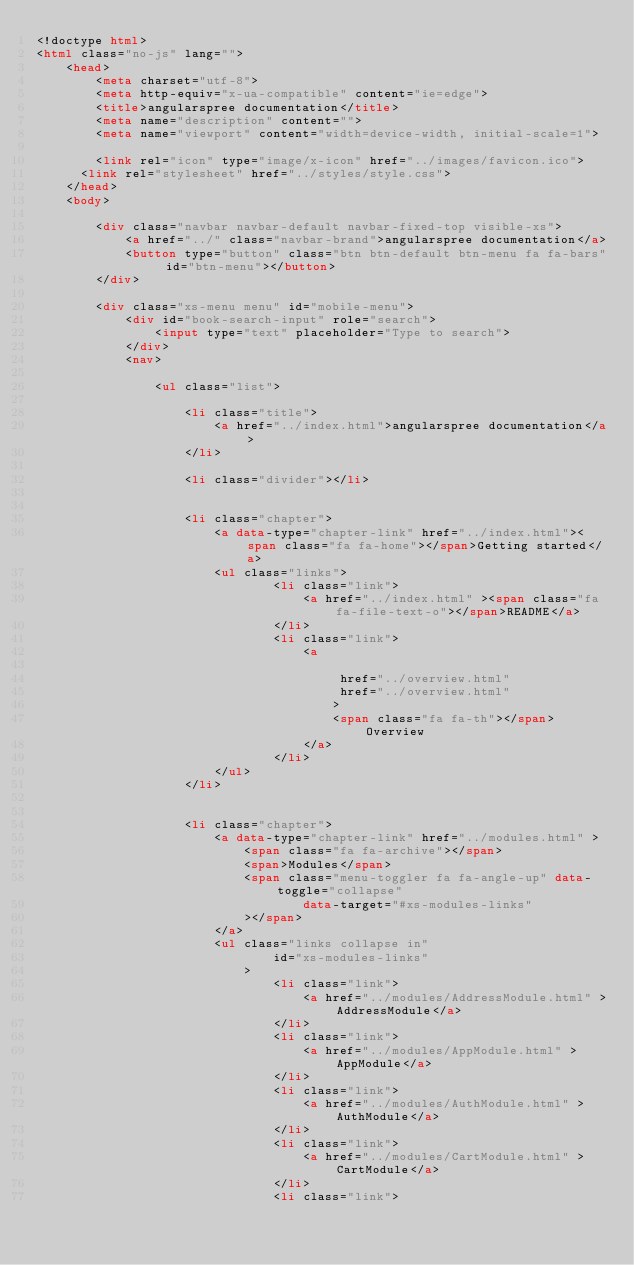Convert code to text. <code><loc_0><loc_0><loc_500><loc_500><_HTML_><!doctype html>
<html class="no-js" lang="">
    <head>
        <meta charset="utf-8">
        <meta http-equiv="x-ua-compatible" content="ie=edge">
        <title>angularspree documentation</title>
        <meta name="description" content="">
        <meta name="viewport" content="width=device-width, initial-scale=1">

        <link rel="icon" type="image/x-icon" href="../images/favicon.ico">
	    <link rel="stylesheet" href="../styles/style.css">
    </head>
    <body>

        <div class="navbar navbar-default navbar-fixed-top visible-xs">
            <a href="../" class="navbar-brand">angularspree documentation</a>
            <button type="button" class="btn btn-default btn-menu fa fa-bars" id="btn-menu"></button>
        </div>

        <div class="xs-menu menu" id="mobile-menu">
            <div id="book-search-input" role="search">
                <input type="text" placeholder="Type to search">
            </div>
            <nav>

                <ul class="list">

                    <li class="title">
                        <a href="../index.html">angularspree documentation</a>
                    </li>

                    <li class="divider"></li>


                    <li class="chapter">
                        <a data-type="chapter-link" href="../index.html"><span class="fa fa-home"></span>Getting started</a>
                        <ul class="links">
                                <li class="link">
                                    <a href="../index.html" ><span class="fa fa-file-text-o"></span>README</a>
                                </li>
                                <li class="link">
                                    <a

                                         href="../overview.html"
                                         href="../overview.html"
                                        >
                                        <span class="fa fa-th"></span>Overview
                                    </a>
                                </li>
                        </ul>
                    </li>


                    <li class="chapter">
                        <a data-type="chapter-link" href="../modules.html" >
                            <span class="fa fa-archive"></span>
                            <span>Modules</span>
                            <span class="menu-toggler fa fa-angle-up" data-toggle="collapse"
                                    data-target="#xs-modules-links"
                            ></span>
                        </a>
                        <ul class="links collapse in"
                                id="xs-modules-links"
                            >
                                <li class="link">
                                    <a href="../modules/AddressModule.html" >AddressModule</a>
                                </li>
                                <li class="link">
                                    <a href="../modules/AppModule.html" >AppModule</a>
                                </li>
                                <li class="link">
                                    <a href="../modules/AuthModule.html" >AuthModule</a>
                                </li>
                                <li class="link">
                                    <a href="../modules/CartModule.html" >CartModule</a>
                                </li>
                                <li class="link"></code> 